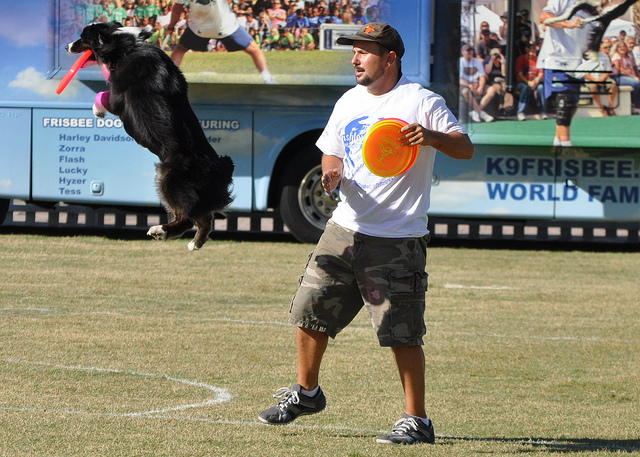Why did the dog jump in the air?
A. flip
B. greet
C. eat
D. catch
Answer with the option's letter from the given choices directly. D 